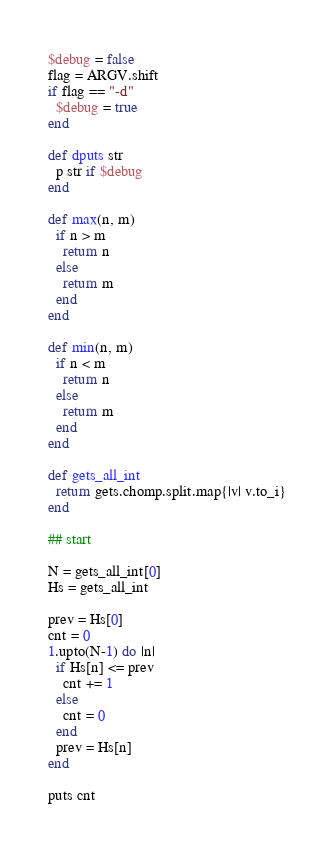<code> <loc_0><loc_0><loc_500><loc_500><_Ruby_>$debug = false
flag = ARGV.shift
if flag == "-d"
  $debug = true
end

def dputs str
  p str if $debug
end

def max(n, m)
  if n > m
    return n
  else
    return m
  end
end

def min(n, m)
  if n < m
    return n
  else
    return m
  end
end

def gets_all_int
  return gets.chomp.split.map{|v| v.to_i}
end

## start

N = gets_all_int[0]
Hs = gets_all_int

prev = Hs[0]
cnt = 0
1.upto(N-1) do |n|
  if Hs[n] <= prev
    cnt += 1
  else
    cnt = 0
  end
  prev = Hs[n]
end

puts cnt</code> 